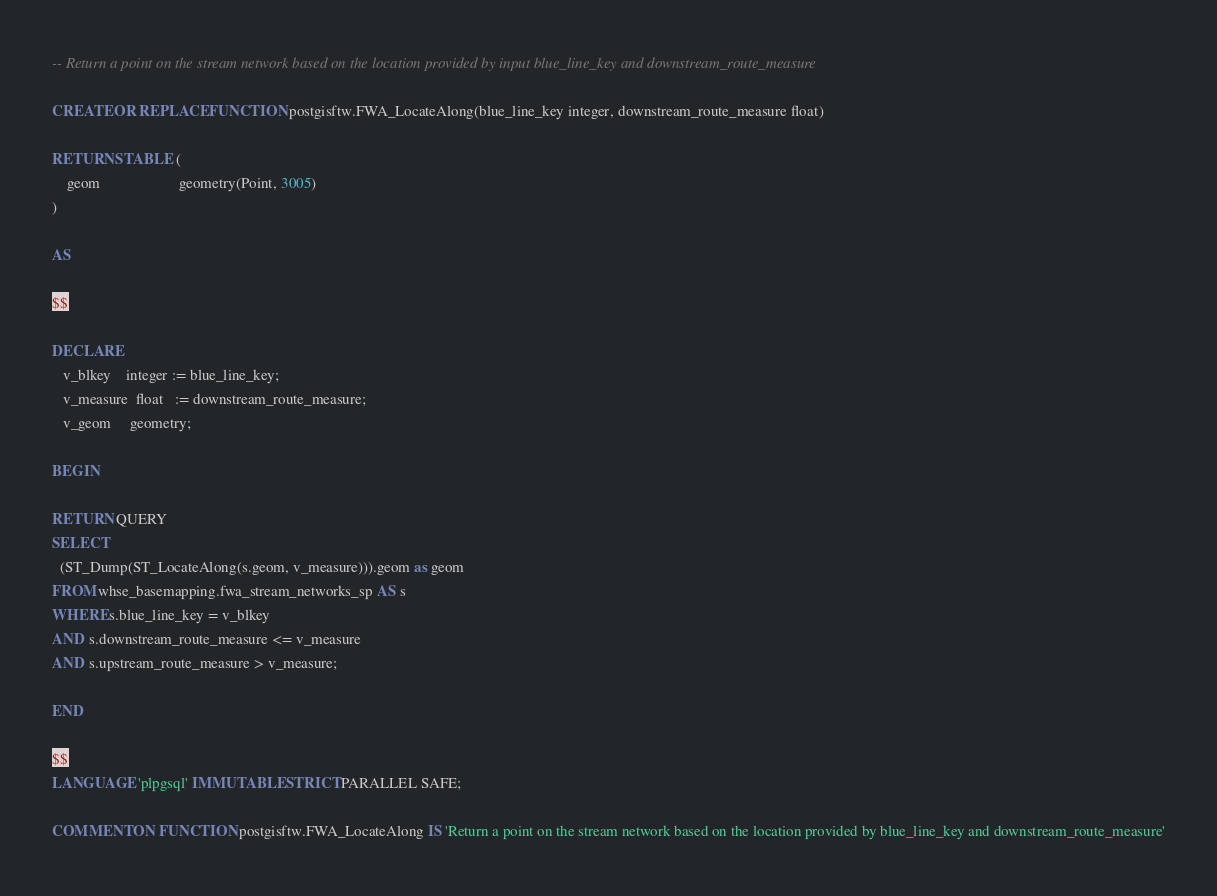<code> <loc_0><loc_0><loc_500><loc_500><_SQL_>-- Return a point on the stream network based on the location provided by input blue_line_key and downstream_route_measure

CREATE OR REPLACE FUNCTION postgisftw.FWA_LocateAlong(blue_line_key integer, downstream_route_measure float)

RETURNS TABLE (
    geom                     geometry(Point, 3005)
)

AS

$$

DECLARE
   v_blkey    integer := blue_line_key;
   v_measure  float   := downstream_route_measure;
   v_geom     geometry;

BEGIN

RETURN QUERY
SELECT
  (ST_Dump(ST_LocateAlong(s.geom, v_measure))).geom as geom
FROM whse_basemapping.fwa_stream_networks_sp AS s
WHERE s.blue_line_key = v_blkey
AND s.downstream_route_measure <= v_measure
AND s.upstream_route_measure > v_measure;

END

$$
LANGUAGE 'plpgsql' IMMUTABLE STRICT PARALLEL SAFE;

COMMENT ON FUNCTION postgisftw.FWA_LocateAlong IS 'Return a point on the stream network based on the location provided by blue_line_key and downstream_route_measure'</code> 